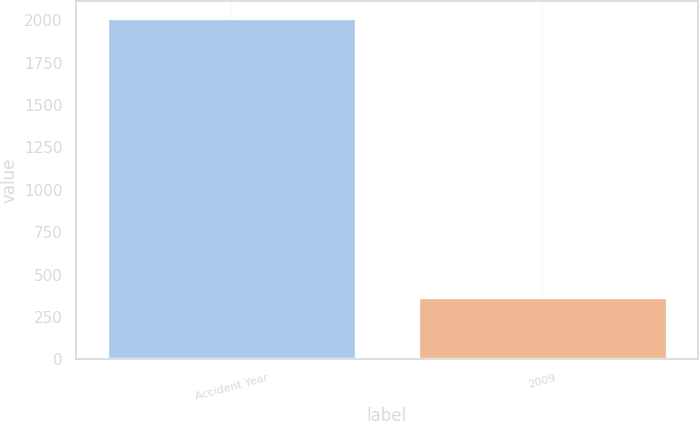Convert chart. <chart><loc_0><loc_0><loc_500><loc_500><bar_chart><fcel>Accident Year<fcel>2009<nl><fcel>2013<fcel>368<nl></chart> 